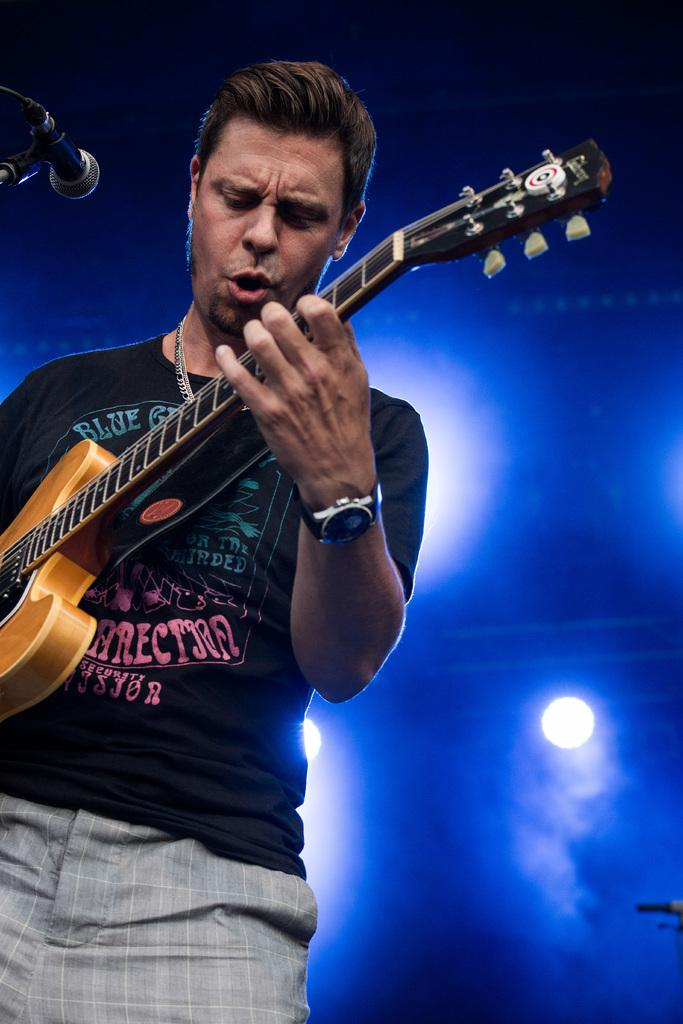What is the man in the image doing? The man is standing and playing a guitar, and he is also singing. What is the man wearing in the image? The man is wearing a black t-shirt. What object is in front of the man? There is a microphone in front of the man. Can you describe any accessories the man is wearing? The man has a watch on his left hand. What can be seen in the background of the image? There are lights visible in the background of the image. What type of yoke is the man using to control the sound of his voice in the image? There is no yoke present in the image, and the man is using a microphone to control the sound of his voice. What type of dress is the man wearing in the image? The man is wearing a black t-shirt, not a dress. 